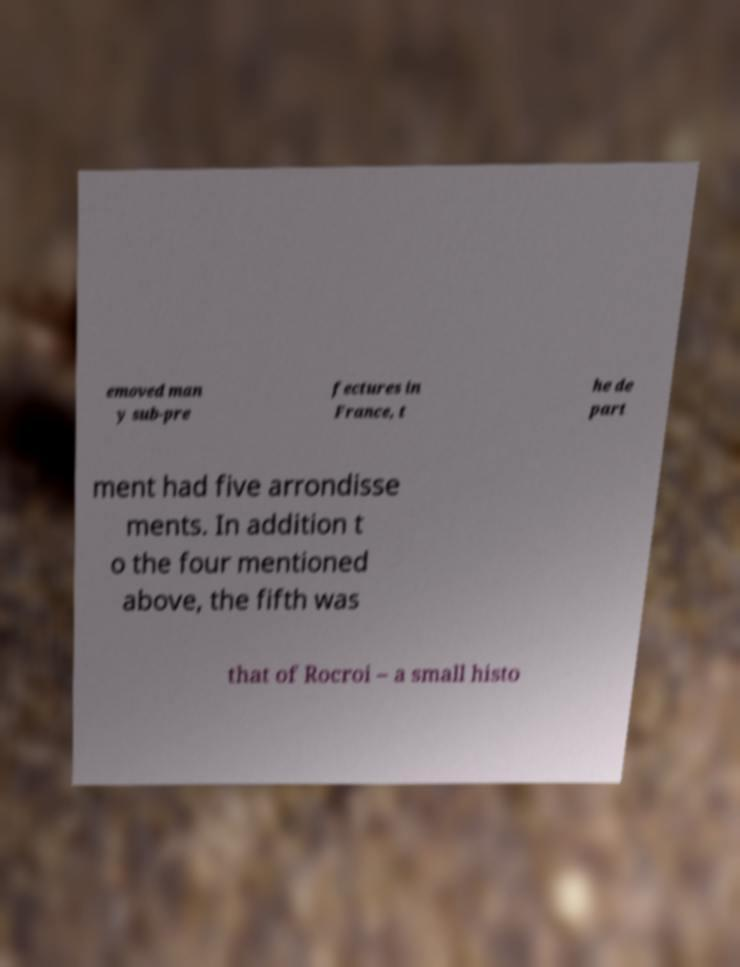Please read and relay the text visible in this image. What does it say? emoved man y sub-pre fectures in France, t he de part ment had five arrondisse ments. In addition t o the four mentioned above, the fifth was that of Rocroi – a small histo 